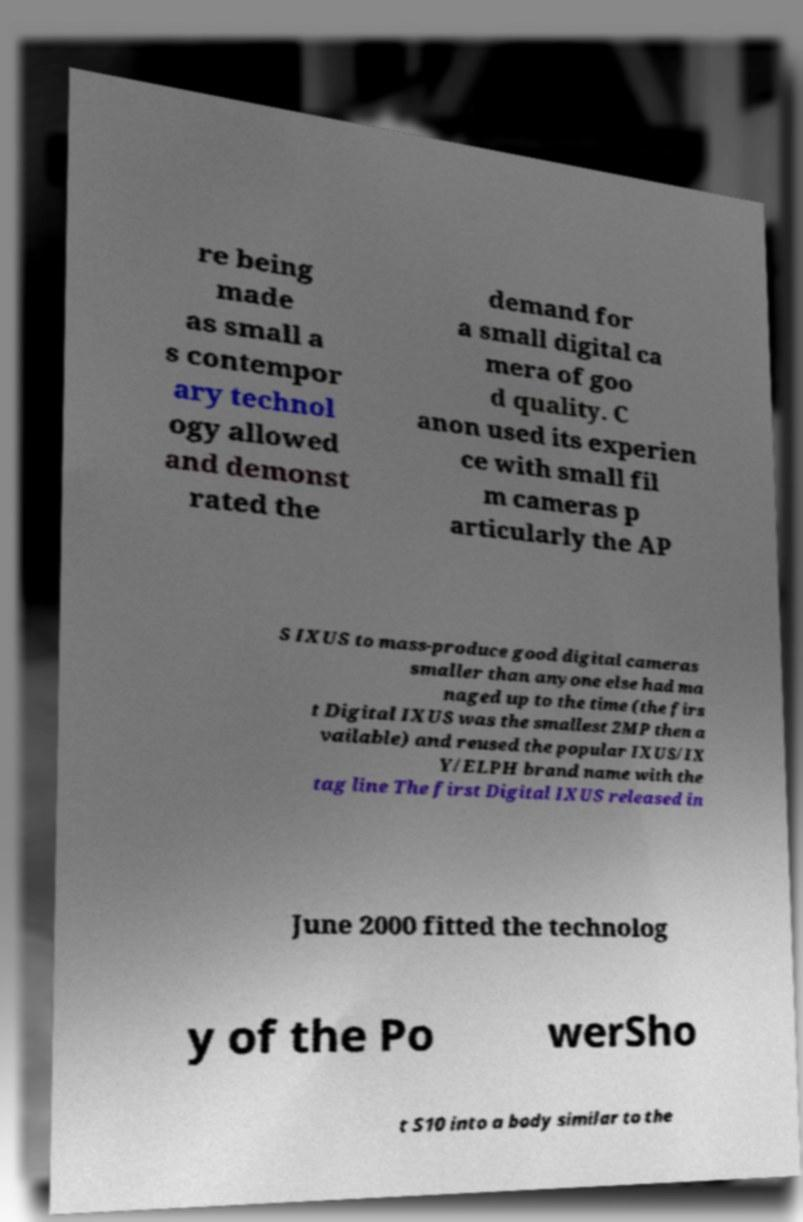Please read and relay the text visible in this image. What does it say? re being made as small a s contempor ary technol ogy allowed and demonst rated the demand for a small digital ca mera of goo d quality. C anon used its experien ce with small fil m cameras p articularly the AP S IXUS to mass-produce good digital cameras smaller than anyone else had ma naged up to the time (the firs t Digital IXUS was the smallest 2MP then a vailable) and reused the popular IXUS/IX Y/ELPH brand name with the tag line The first Digital IXUS released in June 2000 fitted the technolog y of the Po werSho t S10 into a body similar to the 